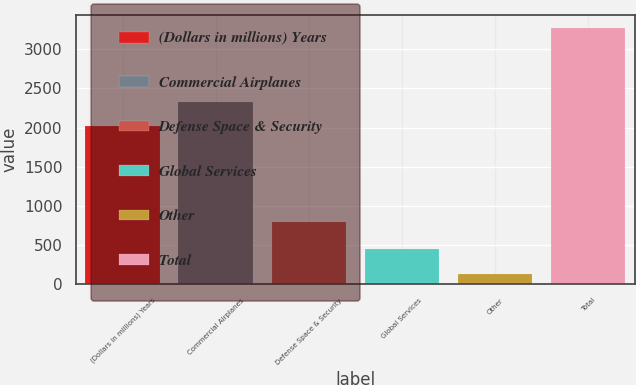Convert chart to OTSL. <chart><loc_0><loc_0><loc_500><loc_500><bar_chart><fcel>(Dollars in millions) Years<fcel>Commercial Airplanes<fcel>Defense Space & Security<fcel>Global Services<fcel>Other<fcel>Total<nl><fcel>2018<fcel>2331.7<fcel>788<fcel>445.7<fcel>132<fcel>3269<nl></chart> 